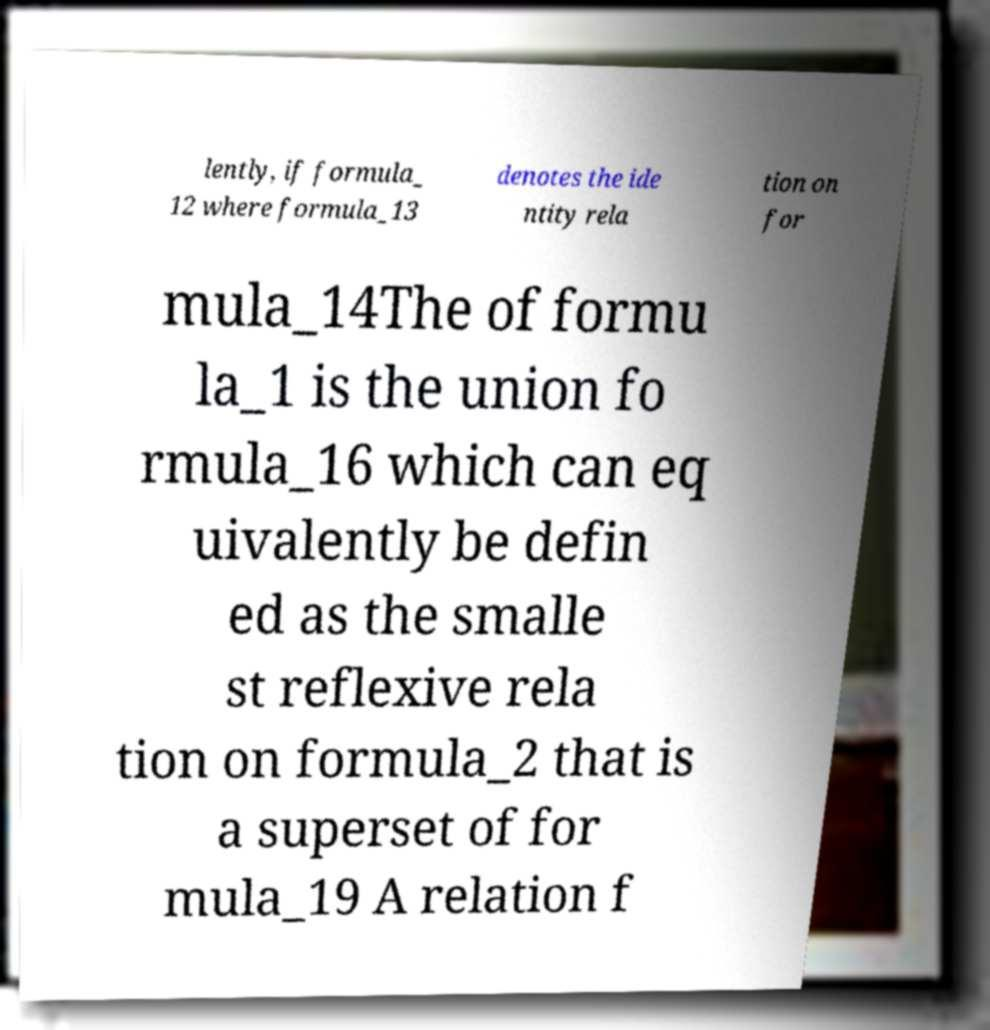I need the written content from this picture converted into text. Can you do that? lently, if formula_ 12 where formula_13 denotes the ide ntity rela tion on for mula_14The of formu la_1 is the union fo rmula_16 which can eq uivalently be defin ed as the smalle st reflexive rela tion on formula_2 that is a superset of for mula_19 A relation f 